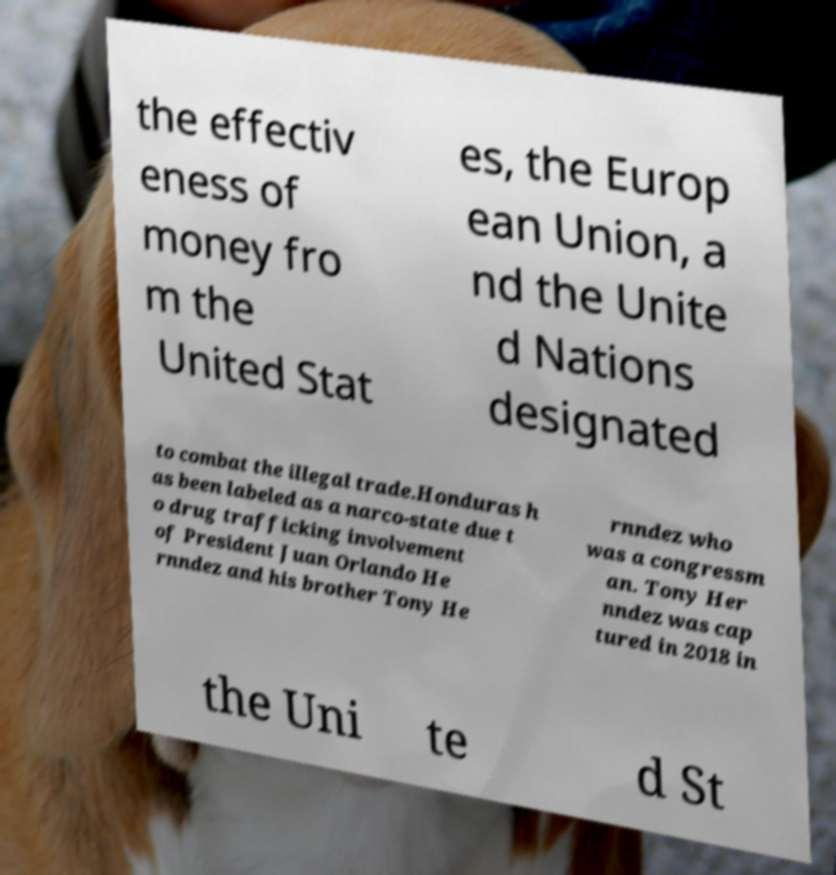What messages or text are displayed in this image? I need them in a readable, typed format. the effectiv eness of money fro m the United Stat es, the Europ ean Union, a nd the Unite d Nations designated to combat the illegal trade.Honduras h as been labeled as a narco-state due t o drug trafficking involvement of President Juan Orlando He rnndez and his brother Tony He rnndez who was a congressm an. Tony Her nndez was cap tured in 2018 in the Uni te d St 